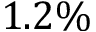<formula> <loc_0><loc_0><loc_500><loc_500>1 . 2 \%</formula> 